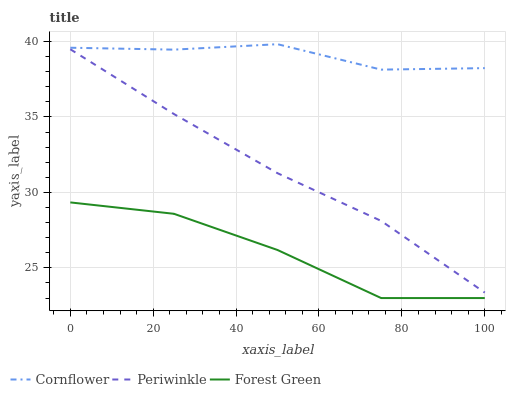Does Forest Green have the minimum area under the curve?
Answer yes or no. Yes. Does Cornflower have the maximum area under the curve?
Answer yes or no. Yes. Does Periwinkle have the minimum area under the curve?
Answer yes or no. No. Does Periwinkle have the maximum area under the curve?
Answer yes or no. No. Is Periwinkle the smoothest?
Answer yes or no. Yes. Is Forest Green the roughest?
Answer yes or no. Yes. Is Forest Green the smoothest?
Answer yes or no. No. Is Periwinkle the roughest?
Answer yes or no. No. Does Forest Green have the lowest value?
Answer yes or no. Yes. Does Periwinkle have the lowest value?
Answer yes or no. No. Does Cornflower have the highest value?
Answer yes or no. Yes. Does Periwinkle have the highest value?
Answer yes or no. No. Is Forest Green less than Periwinkle?
Answer yes or no. Yes. Is Cornflower greater than Forest Green?
Answer yes or no. Yes. Does Forest Green intersect Periwinkle?
Answer yes or no. No. 